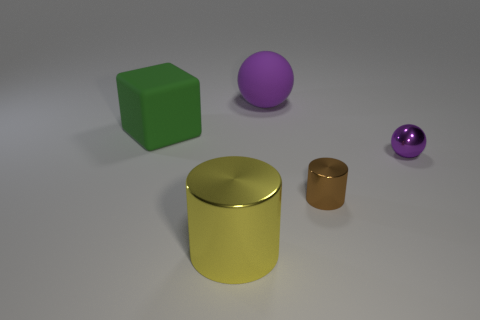Add 1 big cylinders. How many objects exist? 6 Subtract all spheres. How many objects are left? 3 Subtract 0 yellow spheres. How many objects are left? 5 Subtract all tiny brown rubber cylinders. Subtract all green matte things. How many objects are left? 4 Add 5 tiny purple shiny balls. How many tiny purple shiny balls are left? 6 Add 4 large green matte objects. How many large green matte objects exist? 5 